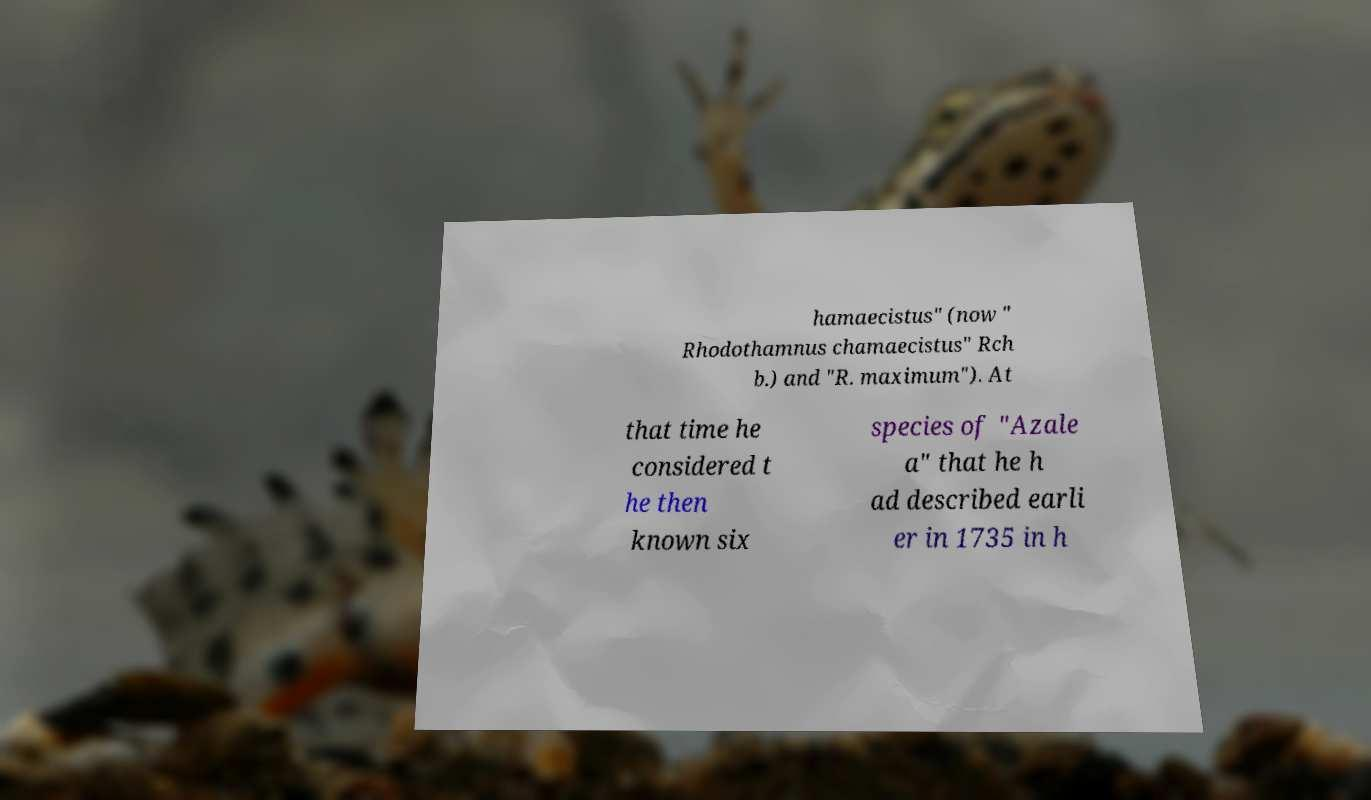Could you extract and type out the text from this image? hamaecistus" (now " Rhodothamnus chamaecistus" Rch b.) and "R. maximum"). At that time he considered t he then known six species of "Azale a" that he h ad described earli er in 1735 in h 